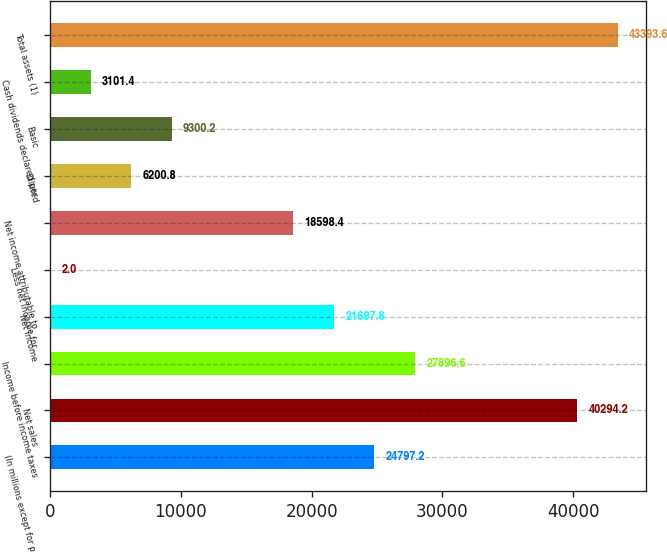Convert chart. <chart><loc_0><loc_0><loc_500><loc_500><bar_chart><fcel>(In millions except for per<fcel>Net sales<fcel>Income before income taxes<fcel>Net income<fcel>Less net income for<fcel>Net income attributable to<fcel>Diluted<fcel>Basic<fcel>Cash dividends declared per<fcel>Total assets (1)<nl><fcel>24797.2<fcel>40294.2<fcel>27896.6<fcel>21697.8<fcel>2<fcel>18598.4<fcel>6200.8<fcel>9300.2<fcel>3101.4<fcel>43393.6<nl></chart> 